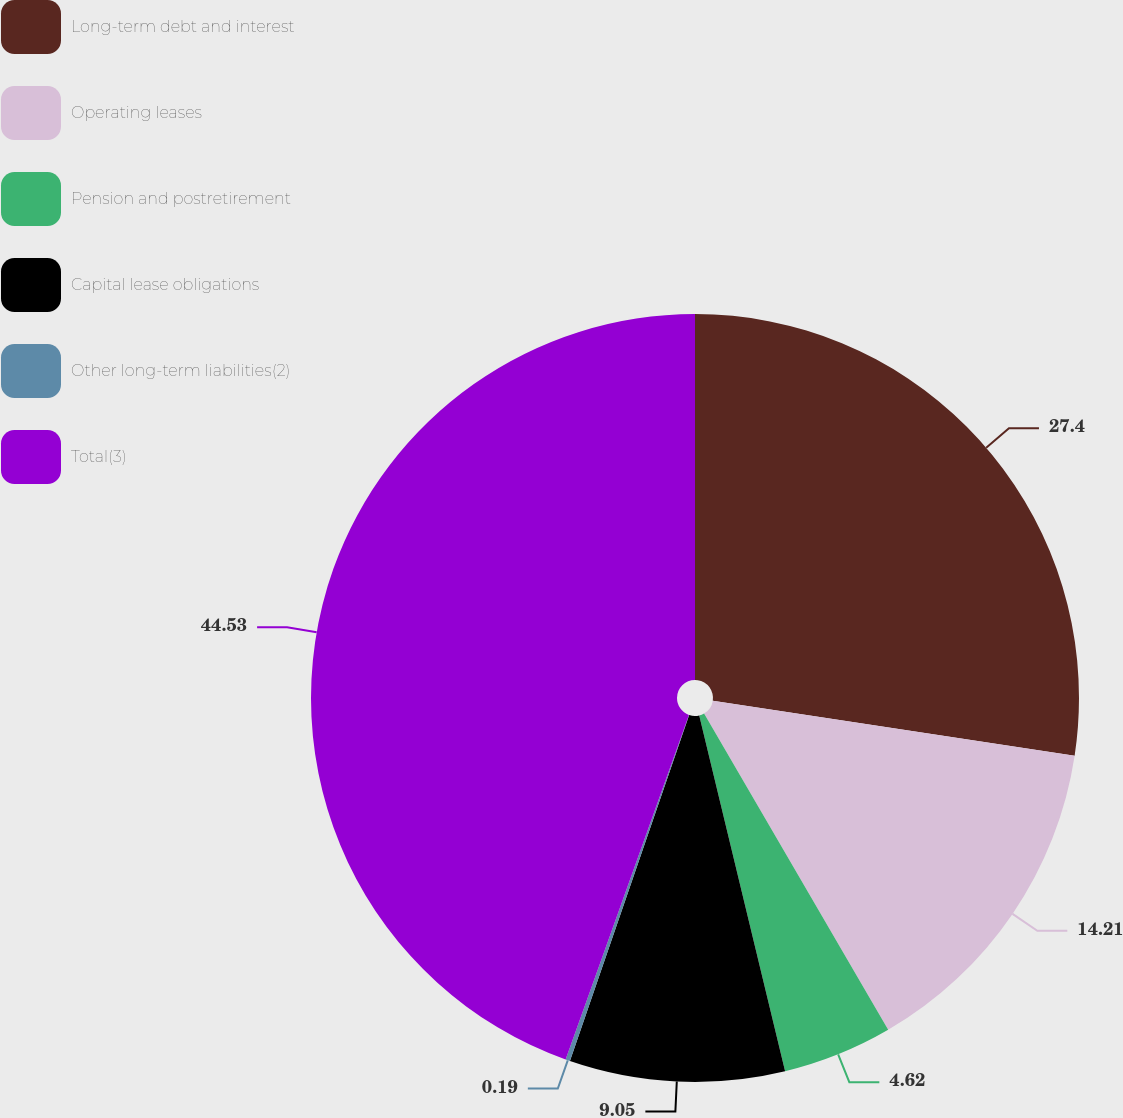Convert chart. <chart><loc_0><loc_0><loc_500><loc_500><pie_chart><fcel>Long-term debt and interest<fcel>Operating leases<fcel>Pension and postretirement<fcel>Capital lease obligations<fcel>Other long-term liabilities(2)<fcel>Total(3)<nl><fcel>27.4%<fcel>14.21%<fcel>4.62%<fcel>9.05%<fcel>0.19%<fcel>44.53%<nl></chart> 